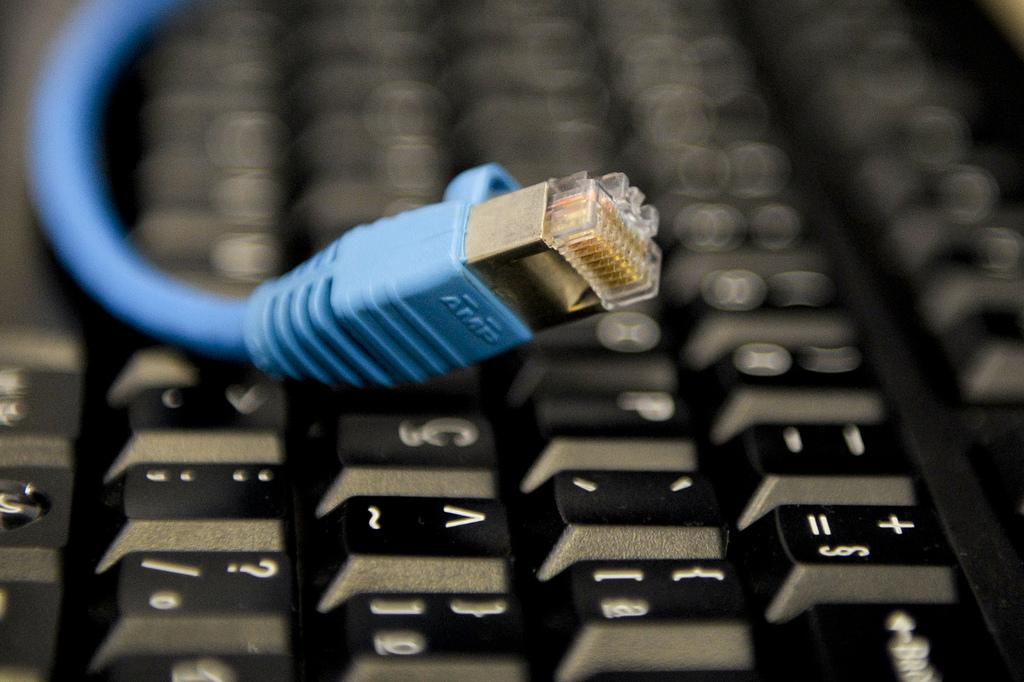<image>
Provide a brief description of the given image. a USB cord is laying on a keyboard with the tip near the C 